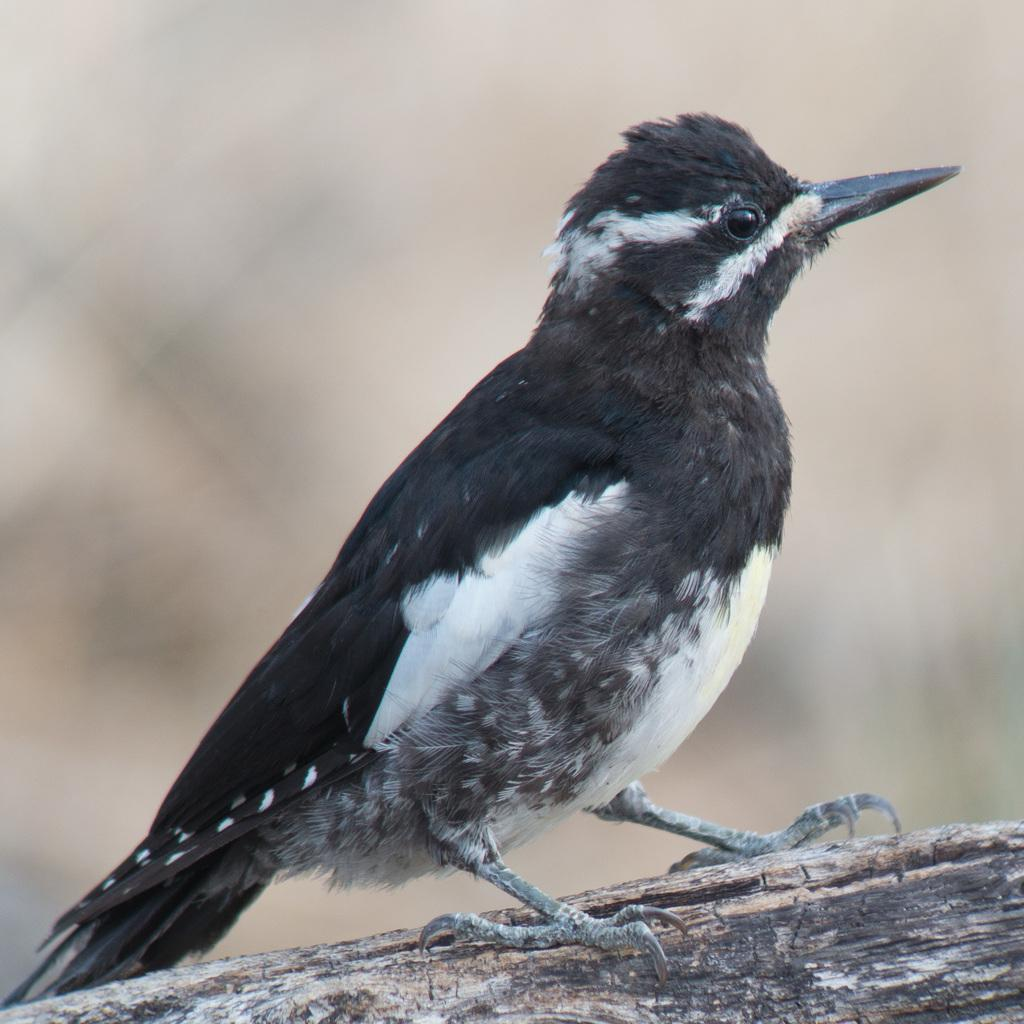What is the main subject in the front of the image? There is a bird in the front of the image. Can you describe the background of the image? The background of the image is blurry. How many goldfish can be seen swimming with the bird in the image? There are no goldfish present in the image; it features a bird in the front and a blurry background. What type of dinosaur is depicted in the image? There are no dinosaurs present in the image; it features a bird in the front and a blurry background. 